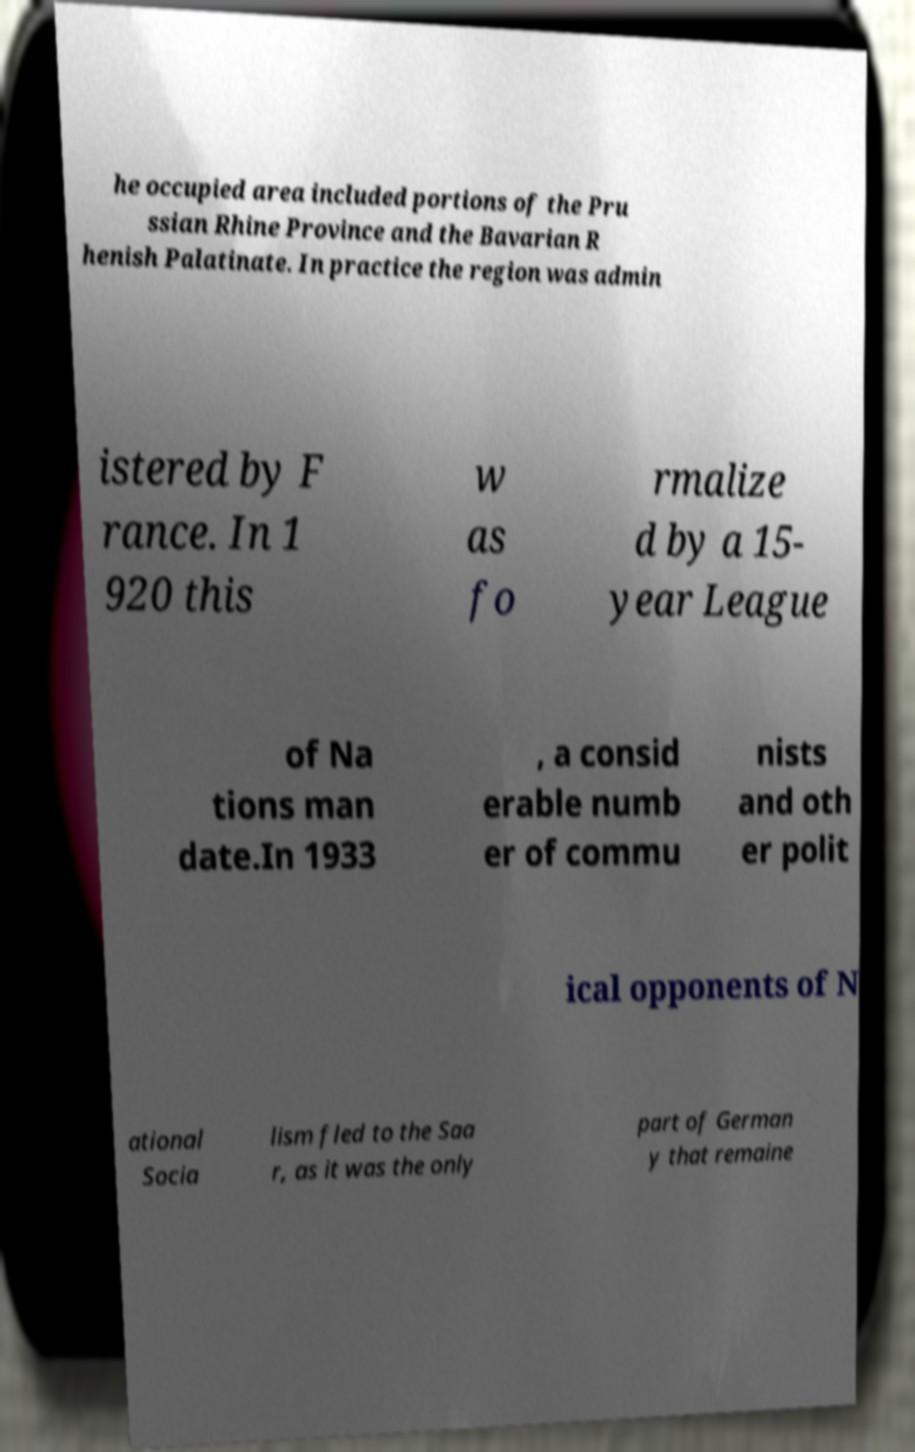Can you read and provide the text displayed in the image?This photo seems to have some interesting text. Can you extract and type it out for me? he occupied area included portions of the Pru ssian Rhine Province and the Bavarian R henish Palatinate. In practice the region was admin istered by F rance. In 1 920 this w as fo rmalize d by a 15- year League of Na tions man date.In 1933 , a consid erable numb er of commu nists and oth er polit ical opponents of N ational Socia lism fled to the Saa r, as it was the only part of German y that remaine 